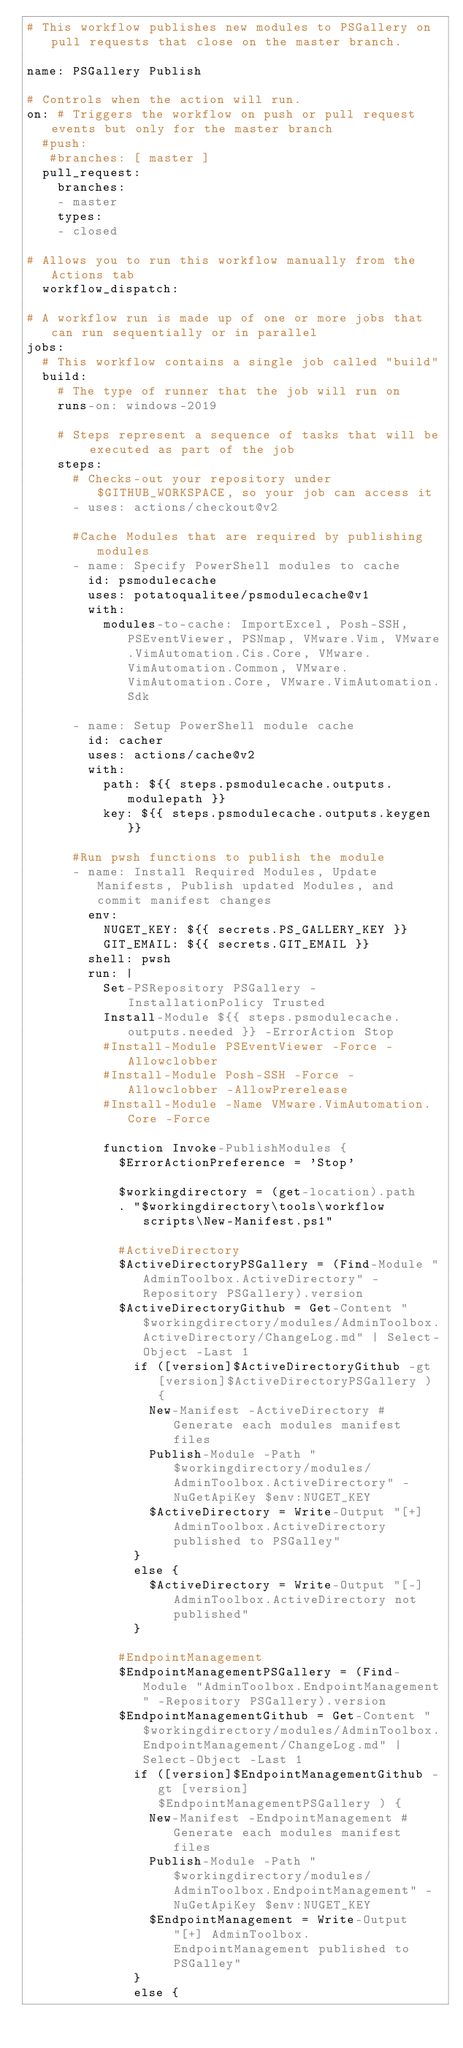Convert code to text. <code><loc_0><loc_0><loc_500><loc_500><_YAML_># This workflow publishes new modules to PSGallery on pull requests that close on the master branch.

name: PSGallery Publish

# Controls when the action will run.
on: # Triggers the workflow on push or pull request events but only for the master branch
  #push:
   #branches: [ master ]
  pull_request:
    branches:
    - master
    types:
    - closed

# Allows you to run this workflow manually from the Actions tab
  workflow_dispatch:

# A workflow run is made up of one or more jobs that can run sequentially or in parallel
jobs:
  # This workflow contains a single job called "build"
  build:
    # The type of runner that the job will run on
    runs-on: windows-2019

    # Steps represent a sequence of tasks that will be executed as part of the job
    steps:
      # Checks-out your repository under $GITHUB_WORKSPACE, so your job can access it
      - uses: actions/checkout@v2

      #Cache Modules that are required by publishing modules
      - name: Specify PowerShell modules to cache
        id: psmodulecache
        uses: potatoqualitee/psmodulecache@v1
        with:
          modules-to-cache: ImportExcel, Posh-SSH, PSEventViewer, PSNmap, VMware.Vim, VMware.VimAutomation.Cis.Core, VMware.VimAutomation.Common, VMware.VimAutomation.Core, VMware.VimAutomation.Sdk

      - name: Setup PowerShell module cache
        id: cacher
        uses: actions/cache@v2
        with:
          path: ${{ steps.psmodulecache.outputs.modulepath }}
          key: ${{ steps.psmodulecache.outputs.keygen }}

      #Run pwsh functions to publish the module
      - name: Install Required Modules, Update Manifests, Publish updated Modules, and commit manifest changes
        env:
          NUGET_KEY: ${{ secrets.PS_GALLERY_KEY }}
          GIT_EMAIL: ${{ secrets.GIT_EMAIL }}
        shell: pwsh
        run: |
          Set-PSRepository PSGallery -InstallationPolicy Trusted
          Install-Module ${{ steps.psmodulecache.outputs.needed }} -ErrorAction Stop
          #Install-Module PSEventViewer -Force -Allowclobber
          #Install-Module Posh-SSH -Force -Allowclobber -AllowPrerelease
          #Install-Module -Name VMware.VimAutomation.Core -Force

          function Invoke-PublishModules {
            $ErrorActionPreference = 'Stop'

            $workingdirectory = (get-location).path
            . "$workingdirectory\tools\workflow scripts\New-Manifest.ps1"

            #ActiveDirectory
            $ActiveDirectoryPSGallery = (Find-Module "AdminToolbox.ActiveDirectory" -Repository PSGallery).version
            $ActiveDirectoryGithub = Get-Content "$workingdirectory/modules/AdminToolbox.ActiveDirectory/ChangeLog.md" | Select-Object -Last 1
              if ([version]$ActiveDirectoryGithub -gt [version]$ActiveDirectoryPSGallery ) {
                New-Manifest -ActiveDirectory #Generate each modules manifest files
                Publish-Module -Path "$workingdirectory/modules/AdminToolbox.ActiveDirectory" -NuGetApiKey $env:NUGET_KEY
                $ActiveDirectory = Write-Output "[+] AdminToolbox.ActiveDirectory published to PSGalley"
              }
              else {
                $ActiveDirectory = Write-Output "[-] AdminToolbox.ActiveDirectory not published"
              }

            #EndpointManagement
            $EndpointManagementPSGallery = (Find-Module "AdminToolbox.EndpointManagement" -Repository PSGallery).version
            $EndpointManagementGithub = Get-Content "$workingdirectory/modules/AdminToolbox.EndpointManagement/ChangeLog.md" | Select-Object -Last 1
              if ([version]$EndpointManagementGithub -gt [version]$EndpointManagementPSGallery ) {
                New-Manifest -EndpointManagement #Generate each modules manifest files
                Publish-Module -Path "$workingdirectory/modules/AdminToolbox.EndpointManagement" -NuGetApiKey $env:NUGET_KEY
                $EndpointManagement = Write-Output "[+] AdminToolbox.EndpointManagement published to PSGalley"
              }
              else {</code> 